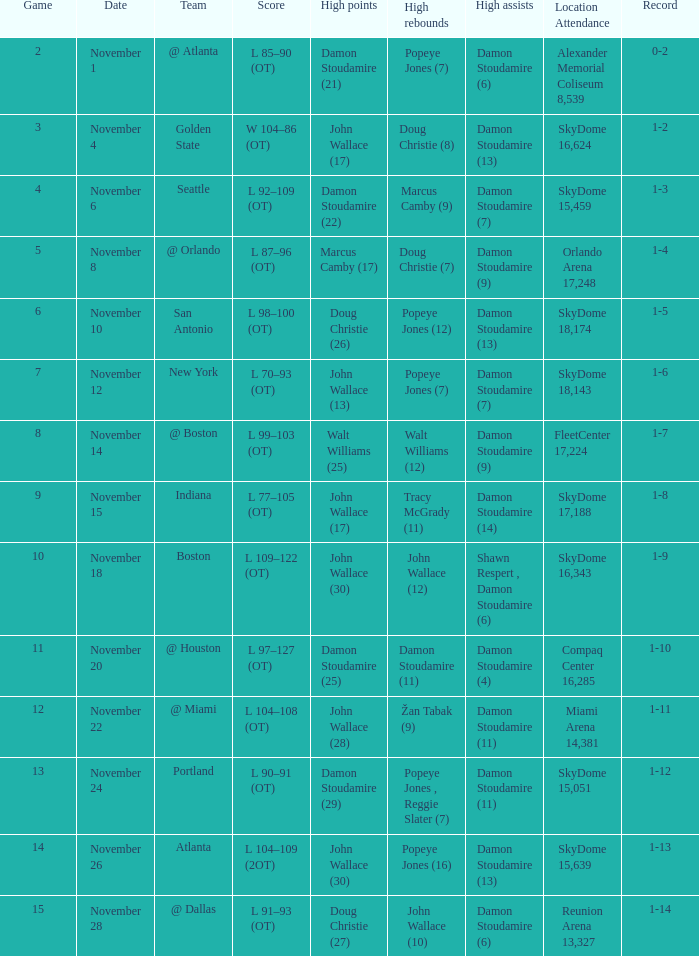What was the score against san antonio? L 98–100 (OT). Can you parse all the data within this table? {'header': ['Game', 'Date', 'Team', 'Score', 'High points', 'High rebounds', 'High assists', 'Location Attendance', 'Record'], 'rows': [['2', 'November 1', '@ Atlanta', 'L 85–90 (OT)', 'Damon Stoudamire (21)', 'Popeye Jones (7)', 'Damon Stoudamire (6)', 'Alexander Memorial Coliseum 8,539', '0-2'], ['3', 'November 4', 'Golden State', 'W 104–86 (OT)', 'John Wallace (17)', 'Doug Christie (8)', 'Damon Stoudamire (13)', 'SkyDome 16,624', '1-2'], ['4', 'November 6', 'Seattle', 'L 92–109 (OT)', 'Damon Stoudamire (22)', 'Marcus Camby (9)', 'Damon Stoudamire (7)', 'SkyDome 15,459', '1-3'], ['5', 'November 8', '@ Orlando', 'L 87–96 (OT)', 'Marcus Camby (17)', 'Doug Christie (7)', 'Damon Stoudamire (9)', 'Orlando Arena 17,248', '1-4'], ['6', 'November 10', 'San Antonio', 'L 98–100 (OT)', 'Doug Christie (26)', 'Popeye Jones (12)', 'Damon Stoudamire (13)', 'SkyDome 18,174', '1-5'], ['7', 'November 12', 'New York', 'L 70–93 (OT)', 'John Wallace (13)', 'Popeye Jones (7)', 'Damon Stoudamire (7)', 'SkyDome 18,143', '1-6'], ['8', 'November 14', '@ Boston', 'L 99–103 (OT)', 'Walt Williams (25)', 'Walt Williams (12)', 'Damon Stoudamire (9)', 'FleetCenter 17,224', '1-7'], ['9', 'November 15', 'Indiana', 'L 77–105 (OT)', 'John Wallace (17)', 'Tracy McGrady (11)', 'Damon Stoudamire (14)', 'SkyDome 17,188', '1-8'], ['10', 'November 18', 'Boston', 'L 109–122 (OT)', 'John Wallace (30)', 'John Wallace (12)', 'Shawn Respert , Damon Stoudamire (6)', 'SkyDome 16,343', '1-9'], ['11', 'November 20', '@ Houston', 'L 97–127 (OT)', 'Damon Stoudamire (25)', 'Damon Stoudamire (11)', 'Damon Stoudamire (4)', 'Compaq Center 16,285', '1-10'], ['12', 'November 22', '@ Miami', 'L 104–108 (OT)', 'John Wallace (28)', 'Žan Tabak (9)', 'Damon Stoudamire (11)', 'Miami Arena 14,381', '1-11'], ['13', 'November 24', 'Portland', 'L 90–91 (OT)', 'Damon Stoudamire (29)', 'Popeye Jones , Reggie Slater (7)', 'Damon Stoudamire (11)', 'SkyDome 15,051', '1-12'], ['14', 'November 26', 'Atlanta', 'L 104–109 (2OT)', 'John Wallace (30)', 'Popeye Jones (16)', 'Damon Stoudamire (13)', 'SkyDome 15,639', '1-13'], ['15', 'November 28', '@ Dallas', 'L 91–93 (OT)', 'Doug Christie (27)', 'John Wallace (10)', 'Damon Stoudamire (6)', 'Reunion Arena 13,327', '1-14']]} 